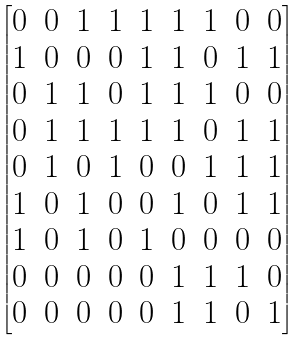<formula> <loc_0><loc_0><loc_500><loc_500>\begin{bmatrix} 0 & 0 & 1 & 1 & 1 & 1 & 1 & 0 & 0 \\ 1 & 0 & 0 & 0 & 1 & 1 & 0 & 1 & 1 \\ 0 & 1 & 1 & 0 & 1 & 1 & 1 & 0 & 0 \\ 0 & 1 & 1 & 1 & 1 & 1 & 0 & 1 & 1 \\ 0 & 1 & 0 & 1 & 0 & 0 & 1 & 1 & 1 \\ 1 & 0 & 1 & 0 & 0 & 1 & 0 & 1 & 1 \\ 1 & 0 & 1 & 0 & 1 & 0 & 0 & 0 & 0 \\ 0 & 0 & 0 & 0 & 0 & 1 & 1 & 1 & 0 \\ 0 & 0 & 0 & 0 & 0 & 1 & 1 & 0 & 1 \end{bmatrix}</formula> 